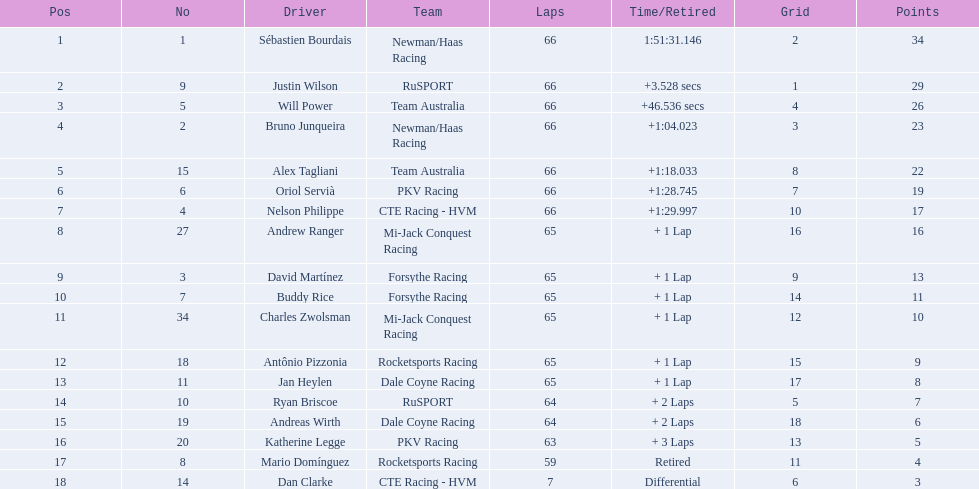What are the names of the drivers who were in position 14 through position 18? Ryan Briscoe, Andreas Wirth, Katherine Legge, Mario Domínguez, Dan Clarke. Of these , which ones didn't finish due to retired or differential? Mario Domínguez, Dan Clarke. Which one of the previous drivers retired? Mario Domínguez. Which of the drivers in question 2 had a differential? Dan Clarke. 